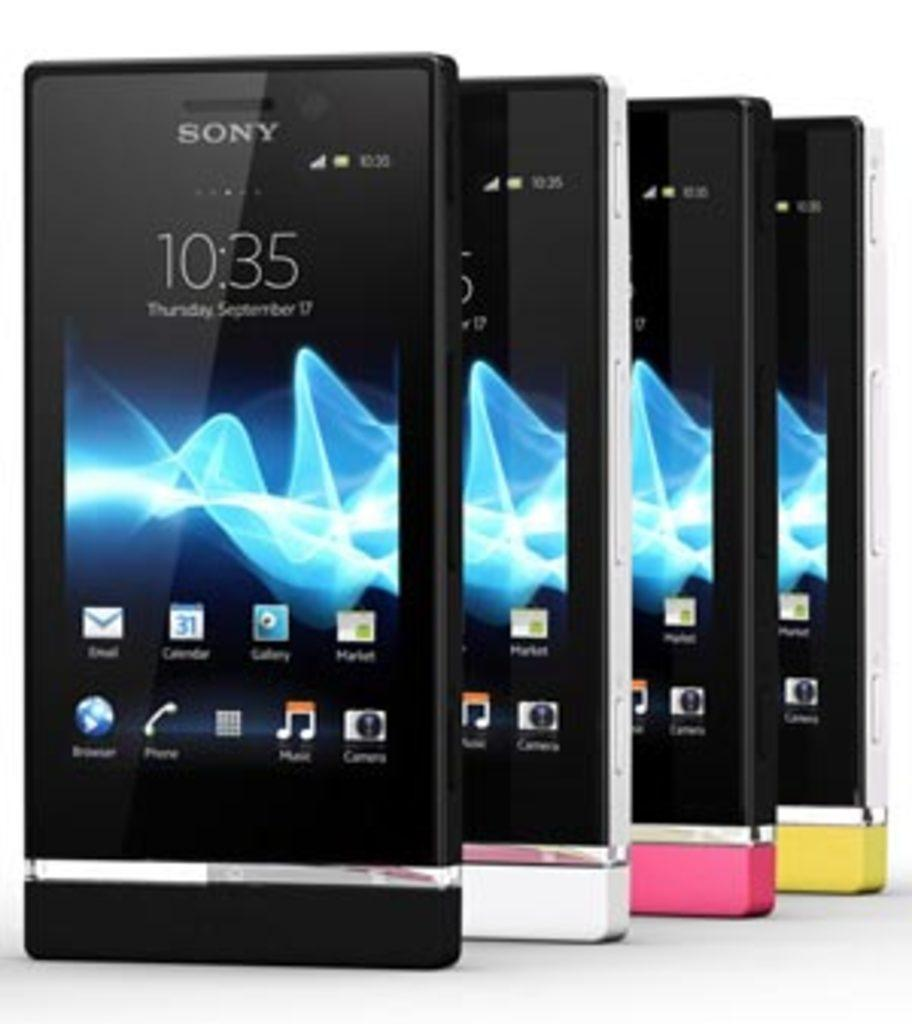<image>
Write a terse but informative summary of the picture. Four Sony cellphones in black, white, pink, and yellow stand propped in a row. 